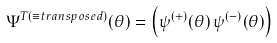Convert formula to latex. <formula><loc_0><loc_0><loc_500><loc_500>\Psi ^ { T ( \equiv t r a n s p o s e d ) } ( \theta ) = \left ( \psi ^ { ( + ) } ( \theta ) \, \psi ^ { ( - ) } ( \theta ) \right )</formula> 